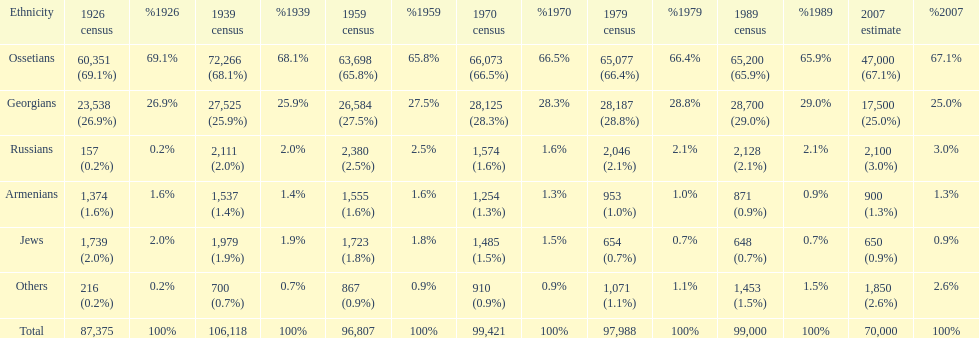Who is previous of the russians based on the list? Georgians. Can you parse all the data within this table? {'header': ['Ethnicity', '1926 census', '%1926', '1939 census', '%1939', '1959 census', '%1959', '1970 census', '%1970', '1979 census', '%1979', '1989 census', '%1989', '2007 estimate', '%2007'], 'rows': [['Ossetians', '60,351 (69.1%)', '69.1%', '72,266 (68.1%)', '68.1%', '63,698 (65.8%)', '65.8%', '66,073 (66.5%)', '66.5%', '65,077 (66.4%)', '66.4%', '65,200 (65.9%)', '65.9%', '47,000 (67.1%)', '67.1%'], ['Georgians', '23,538 (26.9%)', '26.9%', '27,525 (25.9%)', '25.9%', '26,584 (27.5%)', '27.5%', '28,125 (28.3%)', '28.3%', '28,187 (28.8%)', '28.8%', '28,700 (29.0%)', '29.0%', '17,500 (25.0%)', '25.0%'], ['Russians', '157 (0.2%)', '0.2%', '2,111 (2.0%)', '2.0%', '2,380 (2.5%)', '2.5%', '1,574 (1.6%)', '1.6%', '2,046 (2.1%)', '2.1%', '2,128 (2.1%)', '2.1%', '2,100 (3.0%)', '3.0%'], ['Armenians', '1,374 (1.6%)', '1.6%', '1,537 (1.4%)', '1.4%', '1,555 (1.6%)', '1.6%', '1,254 (1.3%)', '1.3%', '953 (1.0%)', '1.0%', '871 (0.9%)', '0.9%', '900 (1.3%)', '1.3%'], ['Jews', '1,739 (2.0%)', '2.0%', '1,979 (1.9%)', '1.9%', '1,723 (1.8%)', '1.8%', '1,485 (1.5%)', '1.5%', '654 (0.7%)', '0.7%', '648 (0.7%)', '0.7%', '650 (0.9%)', '0.9%'], ['Others', '216 (0.2%)', '0.2%', '700 (0.7%)', '0.7%', '867 (0.9%)', '0.9%', '910 (0.9%)', '0.9%', '1,071 (1.1%)', '1.1%', '1,453 (1.5%)', '1.5%', '1,850 (2.6%)', '2.6%'], ['Total', '87,375', '100%', '106,118', '100%', '96,807', '100%', '99,421', '100%', '97,988', '100%', '99,000', '100%', '70,000', '100%']]} 